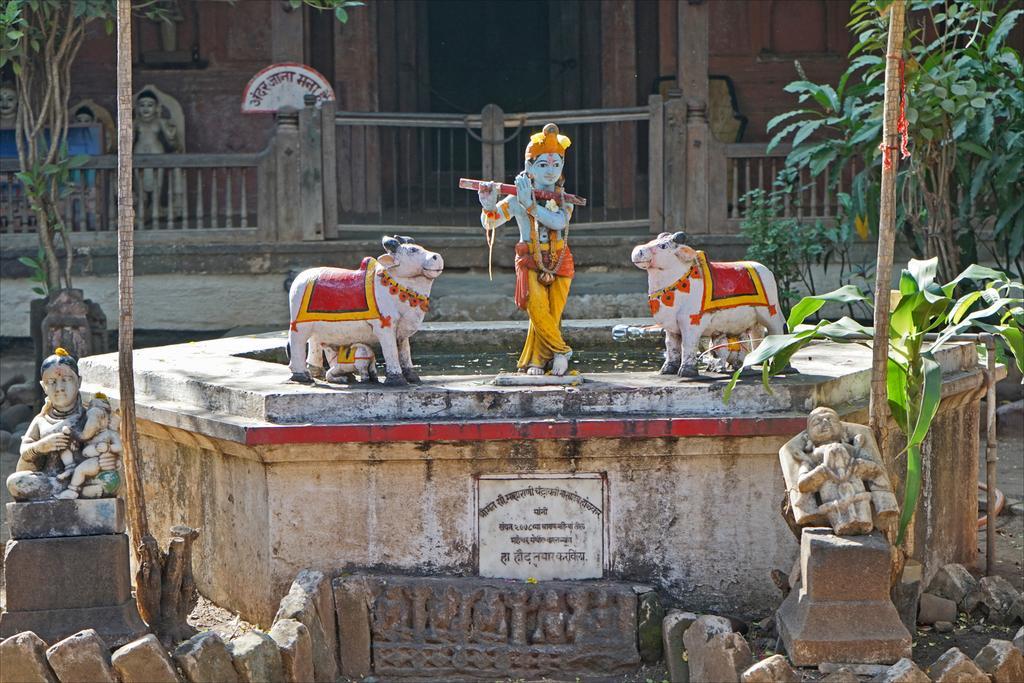Could you give a brief overview of what you see in this image? This image is consists of garden gnomes and there are plants and bamboos on the right and left side of the image and there is a house in the background area of the image, there is a door and a boundary at the top side of the image. 